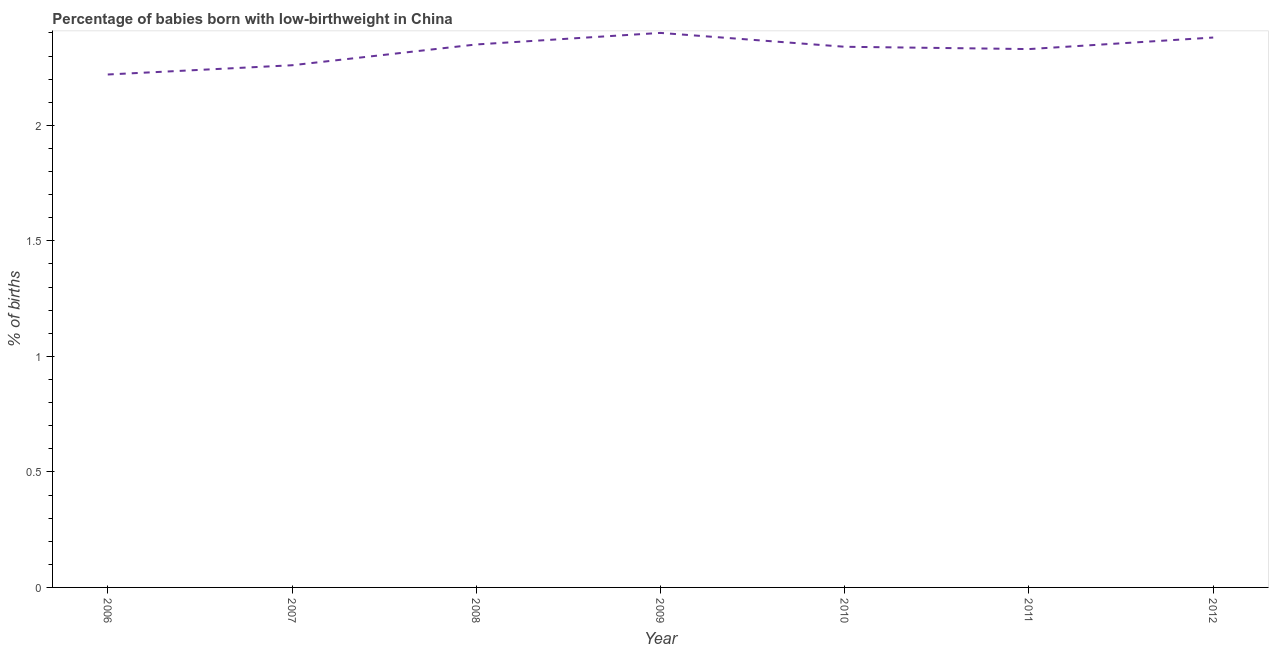What is the percentage of babies who were born with low-birthweight in 2010?
Give a very brief answer. 2.34. Across all years, what is the minimum percentage of babies who were born with low-birthweight?
Your answer should be compact. 2.22. In which year was the percentage of babies who were born with low-birthweight minimum?
Keep it short and to the point. 2006. What is the sum of the percentage of babies who were born with low-birthweight?
Give a very brief answer. 16.28. What is the difference between the percentage of babies who were born with low-birthweight in 2008 and 2011?
Provide a succinct answer. 0.02. What is the average percentage of babies who were born with low-birthweight per year?
Provide a succinct answer. 2.33. What is the median percentage of babies who were born with low-birthweight?
Provide a succinct answer. 2.34. In how many years, is the percentage of babies who were born with low-birthweight greater than 0.9 %?
Provide a short and direct response. 7. Do a majority of the years between 2011 and 2012 (inclusive) have percentage of babies who were born with low-birthweight greater than 0.8 %?
Offer a very short reply. Yes. What is the ratio of the percentage of babies who were born with low-birthweight in 2008 to that in 2009?
Make the answer very short. 0.98. What is the difference between the highest and the second highest percentage of babies who were born with low-birthweight?
Your response must be concise. 0.02. Is the sum of the percentage of babies who were born with low-birthweight in 2007 and 2009 greater than the maximum percentage of babies who were born with low-birthweight across all years?
Your answer should be compact. Yes. What is the difference between the highest and the lowest percentage of babies who were born with low-birthweight?
Ensure brevity in your answer.  0.18. In how many years, is the percentage of babies who were born with low-birthweight greater than the average percentage of babies who were born with low-birthweight taken over all years?
Provide a succinct answer. 5. Does the percentage of babies who were born with low-birthweight monotonically increase over the years?
Provide a succinct answer. No. How many lines are there?
Your response must be concise. 1. What is the difference between two consecutive major ticks on the Y-axis?
Offer a very short reply. 0.5. Does the graph contain any zero values?
Keep it short and to the point. No. Does the graph contain grids?
Give a very brief answer. No. What is the title of the graph?
Offer a terse response. Percentage of babies born with low-birthweight in China. What is the label or title of the X-axis?
Make the answer very short. Year. What is the label or title of the Y-axis?
Give a very brief answer. % of births. What is the % of births of 2006?
Your response must be concise. 2.22. What is the % of births in 2007?
Provide a succinct answer. 2.26. What is the % of births in 2008?
Your answer should be very brief. 2.35. What is the % of births of 2010?
Provide a succinct answer. 2.34. What is the % of births of 2011?
Your answer should be very brief. 2.33. What is the % of births of 2012?
Your answer should be very brief. 2.38. What is the difference between the % of births in 2006 and 2007?
Offer a terse response. -0.04. What is the difference between the % of births in 2006 and 2008?
Your answer should be compact. -0.13. What is the difference between the % of births in 2006 and 2009?
Your answer should be compact. -0.18. What is the difference between the % of births in 2006 and 2010?
Ensure brevity in your answer.  -0.12. What is the difference between the % of births in 2006 and 2011?
Offer a very short reply. -0.11. What is the difference between the % of births in 2006 and 2012?
Your answer should be very brief. -0.16. What is the difference between the % of births in 2007 and 2008?
Make the answer very short. -0.09. What is the difference between the % of births in 2007 and 2009?
Your response must be concise. -0.14. What is the difference between the % of births in 2007 and 2010?
Your response must be concise. -0.08. What is the difference between the % of births in 2007 and 2011?
Provide a short and direct response. -0.07. What is the difference between the % of births in 2007 and 2012?
Make the answer very short. -0.12. What is the difference between the % of births in 2008 and 2012?
Offer a very short reply. -0.03. What is the difference between the % of births in 2009 and 2011?
Your response must be concise. 0.07. What is the difference between the % of births in 2010 and 2012?
Offer a very short reply. -0.04. What is the ratio of the % of births in 2006 to that in 2007?
Offer a very short reply. 0.98. What is the ratio of the % of births in 2006 to that in 2008?
Offer a very short reply. 0.94. What is the ratio of the % of births in 2006 to that in 2009?
Keep it short and to the point. 0.93. What is the ratio of the % of births in 2006 to that in 2010?
Your answer should be compact. 0.95. What is the ratio of the % of births in 2006 to that in 2011?
Keep it short and to the point. 0.95. What is the ratio of the % of births in 2006 to that in 2012?
Ensure brevity in your answer.  0.93. What is the ratio of the % of births in 2007 to that in 2009?
Your answer should be compact. 0.94. What is the ratio of the % of births in 2007 to that in 2011?
Your answer should be compact. 0.97. What is the ratio of the % of births in 2008 to that in 2009?
Make the answer very short. 0.98. What is the ratio of the % of births in 2008 to that in 2010?
Your answer should be very brief. 1. What is the ratio of the % of births in 2008 to that in 2012?
Your response must be concise. 0.99. What is the ratio of the % of births in 2009 to that in 2010?
Make the answer very short. 1.03. What is the ratio of the % of births in 2009 to that in 2011?
Provide a short and direct response. 1.03. What is the ratio of the % of births in 2009 to that in 2012?
Give a very brief answer. 1.01. What is the ratio of the % of births in 2010 to that in 2011?
Give a very brief answer. 1. What is the ratio of the % of births in 2010 to that in 2012?
Your answer should be compact. 0.98. What is the ratio of the % of births in 2011 to that in 2012?
Provide a succinct answer. 0.98. 